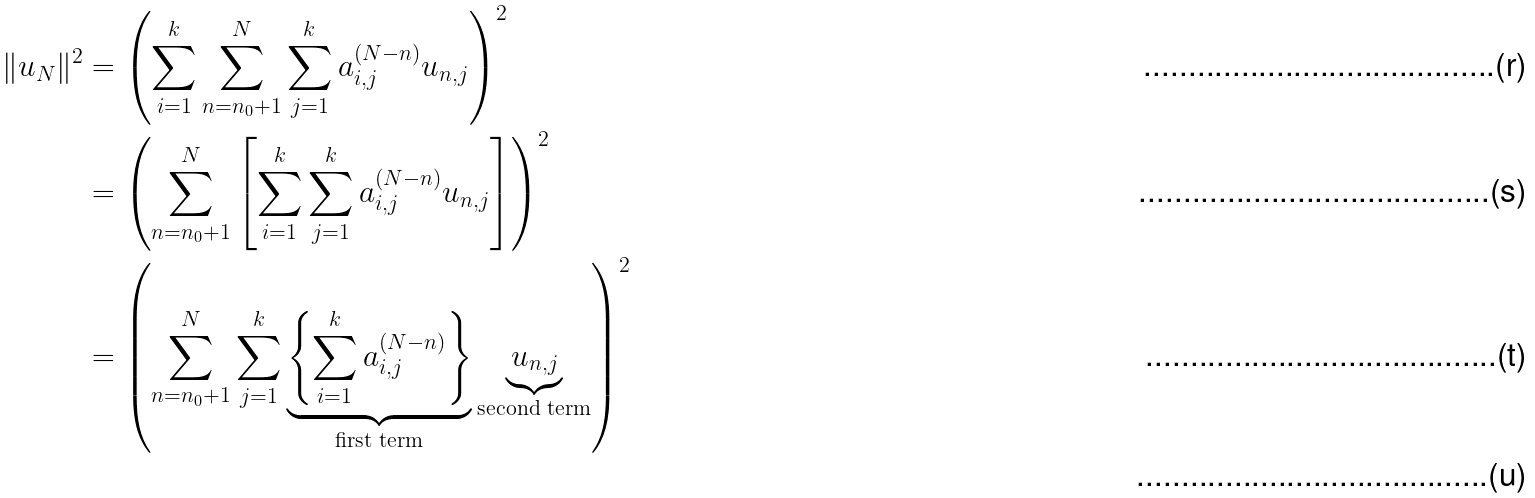Convert formula to latex. <formula><loc_0><loc_0><loc_500><loc_500>\| { u } _ { N } \| ^ { 2 } & = \left ( \sum _ { i = 1 } ^ { k } \sum _ { n = n _ { 0 } + 1 } ^ { N } \sum _ { j = 1 } ^ { k } a _ { i , j } ^ { ( N - n ) } u _ { n , j } \right ) ^ { 2 } \\ & = \left ( \sum _ { n = n _ { 0 } + 1 } ^ { N } \left [ \sum _ { i = 1 } ^ { k } \sum _ { j = 1 } ^ { k } a _ { i , j } ^ { ( N - n ) } u _ { n , j } \right ] \right ) ^ { 2 } \\ & = \left ( \sum _ { n = n _ { 0 } + 1 } ^ { N } \sum _ { j = 1 } ^ { k } \underbrace { \left \{ \sum _ { i = 1 } ^ { k } a _ { i , j } ^ { ( N - n ) } \right \} } _ { \text {first term} } \underbrace { u _ { n , j } } _ { \text {second term} } \right ) ^ { 2 } \\</formula> 